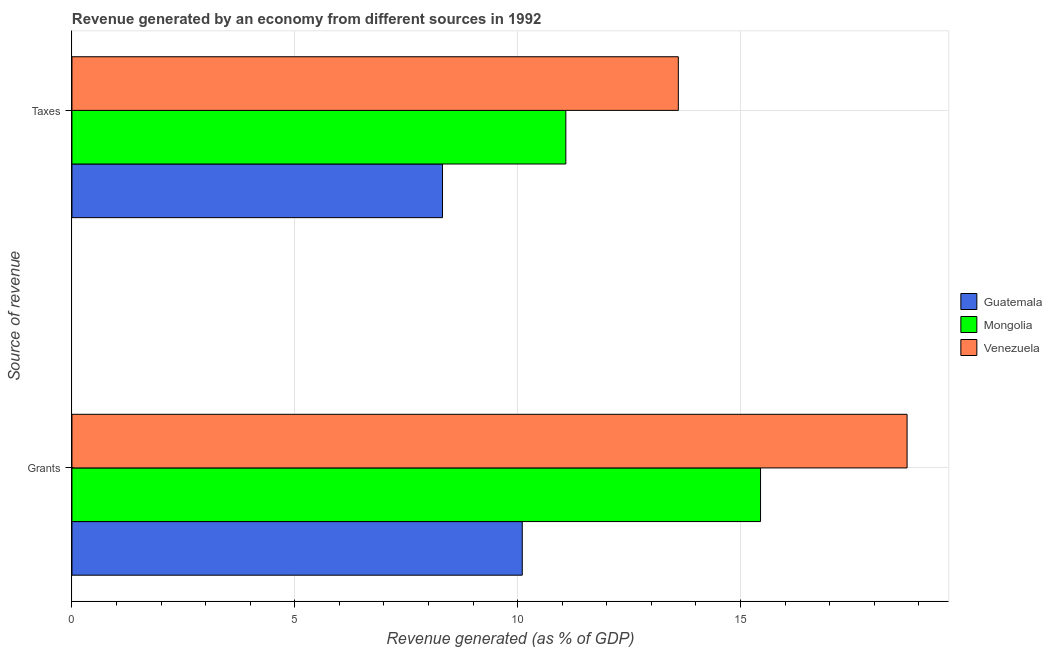How many groups of bars are there?
Your answer should be compact. 2. Are the number of bars per tick equal to the number of legend labels?
Ensure brevity in your answer.  Yes. Are the number of bars on each tick of the Y-axis equal?
Your response must be concise. Yes. What is the label of the 2nd group of bars from the top?
Ensure brevity in your answer.  Grants. What is the revenue generated by grants in Mongolia?
Your answer should be compact. 15.45. Across all countries, what is the maximum revenue generated by taxes?
Give a very brief answer. 13.6. Across all countries, what is the minimum revenue generated by taxes?
Give a very brief answer. 8.31. In which country was the revenue generated by taxes maximum?
Your response must be concise. Venezuela. In which country was the revenue generated by taxes minimum?
Offer a very short reply. Guatemala. What is the total revenue generated by grants in the graph?
Offer a terse response. 44.29. What is the difference between the revenue generated by taxes in Venezuela and that in Mongolia?
Provide a succinct answer. 2.52. What is the difference between the revenue generated by taxes in Guatemala and the revenue generated by grants in Mongolia?
Your answer should be compact. -7.14. What is the average revenue generated by grants per country?
Offer a terse response. 14.76. What is the difference between the revenue generated by grants and revenue generated by taxes in Venezuela?
Your response must be concise. 5.13. In how many countries, is the revenue generated by taxes greater than 13 %?
Provide a succinct answer. 1. What is the ratio of the revenue generated by taxes in Guatemala to that in Venezuela?
Provide a short and direct response. 0.61. Is the revenue generated by grants in Venezuela less than that in Mongolia?
Ensure brevity in your answer.  No. In how many countries, is the revenue generated by grants greater than the average revenue generated by grants taken over all countries?
Offer a terse response. 2. What does the 2nd bar from the top in Grants represents?
Ensure brevity in your answer.  Mongolia. What does the 2nd bar from the bottom in Grants represents?
Give a very brief answer. Mongolia. What is the difference between two consecutive major ticks on the X-axis?
Offer a terse response. 5. Does the graph contain any zero values?
Make the answer very short. No. Does the graph contain grids?
Your answer should be compact. Yes. How many legend labels are there?
Give a very brief answer. 3. How are the legend labels stacked?
Ensure brevity in your answer.  Vertical. What is the title of the graph?
Offer a terse response. Revenue generated by an economy from different sources in 1992. What is the label or title of the X-axis?
Give a very brief answer. Revenue generated (as % of GDP). What is the label or title of the Y-axis?
Your response must be concise. Source of revenue. What is the Revenue generated (as % of GDP) of Guatemala in Grants?
Provide a short and direct response. 10.1. What is the Revenue generated (as % of GDP) in Mongolia in Grants?
Ensure brevity in your answer.  15.45. What is the Revenue generated (as % of GDP) of Venezuela in Grants?
Offer a terse response. 18.74. What is the Revenue generated (as % of GDP) in Guatemala in Taxes?
Offer a very short reply. 8.31. What is the Revenue generated (as % of GDP) in Mongolia in Taxes?
Offer a very short reply. 11.08. What is the Revenue generated (as % of GDP) in Venezuela in Taxes?
Provide a short and direct response. 13.6. Across all Source of revenue, what is the maximum Revenue generated (as % of GDP) in Guatemala?
Your answer should be very brief. 10.1. Across all Source of revenue, what is the maximum Revenue generated (as % of GDP) of Mongolia?
Provide a short and direct response. 15.45. Across all Source of revenue, what is the maximum Revenue generated (as % of GDP) of Venezuela?
Make the answer very short. 18.74. Across all Source of revenue, what is the minimum Revenue generated (as % of GDP) in Guatemala?
Keep it short and to the point. 8.31. Across all Source of revenue, what is the minimum Revenue generated (as % of GDP) in Mongolia?
Keep it short and to the point. 11.08. Across all Source of revenue, what is the minimum Revenue generated (as % of GDP) of Venezuela?
Offer a very short reply. 13.6. What is the total Revenue generated (as % of GDP) of Guatemala in the graph?
Make the answer very short. 18.42. What is the total Revenue generated (as % of GDP) in Mongolia in the graph?
Keep it short and to the point. 26.53. What is the total Revenue generated (as % of GDP) of Venezuela in the graph?
Provide a short and direct response. 32.34. What is the difference between the Revenue generated (as % of GDP) in Guatemala in Grants and that in Taxes?
Ensure brevity in your answer.  1.79. What is the difference between the Revenue generated (as % of GDP) in Mongolia in Grants and that in Taxes?
Provide a succinct answer. 4.37. What is the difference between the Revenue generated (as % of GDP) of Venezuela in Grants and that in Taxes?
Keep it short and to the point. 5.13. What is the difference between the Revenue generated (as % of GDP) of Guatemala in Grants and the Revenue generated (as % of GDP) of Mongolia in Taxes?
Your answer should be very brief. -0.98. What is the difference between the Revenue generated (as % of GDP) of Guatemala in Grants and the Revenue generated (as % of GDP) of Venezuela in Taxes?
Provide a short and direct response. -3.5. What is the difference between the Revenue generated (as % of GDP) of Mongolia in Grants and the Revenue generated (as % of GDP) of Venezuela in Taxes?
Offer a very short reply. 1.84. What is the average Revenue generated (as % of GDP) in Guatemala per Source of revenue?
Provide a succinct answer. 9.21. What is the average Revenue generated (as % of GDP) of Mongolia per Source of revenue?
Offer a terse response. 13.27. What is the average Revenue generated (as % of GDP) of Venezuela per Source of revenue?
Give a very brief answer. 16.17. What is the difference between the Revenue generated (as % of GDP) in Guatemala and Revenue generated (as % of GDP) in Mongolia in Grants?
Your answer should be very brief. -5.35. What is the difference between the Revenue generated (as % of GDP) in Guatemala and Revenue generated (as % of GDP) in Venezuela in Grants?
Your answer should be very brief. -8.63. What is the difference between the Revenue generated (as % of GDP) of Mongolia and Revenue generated (as % of GDP) of Venezuela in Grants?
Provide a short and direct response. -3.29. What is the difference between the Revenue generated (as % of GDP) in Guatemala and Revenue generated (as % of GDP) in Mongolia in Taxes?
Offer a terse response. -2.77. What is the difference between the Revenue generated (as % of GDP) in Guatemala and Revenue generated (as % of GDP) in Venezuela in Taxes?
Your answer should be compact. -5.29. What is the difference between the Revenue generated (as % of GDP) of Mongolia and Revenue generated (as % of GDP) of Venezuela in Taxes?
Keep it short and to the point. -2.52. What is the ratio of the Revenue generated (as % of GDP) of Guatemala in Grants to that in Taxes?
Your response must be concise. 1.22. What is the ratio of the Revenue generated (as % of GDP) of Mongolia in Grants to that in Taxes?
Your answer should be very brief. 1.39. What is the ratio of the Revenue generated (as % of GDP) of Venezuela in Grants to that in Taxes?
Give a very brief answer. 1.38. What is the difference between the highest and the second highest Revenue generated (as % of GDP) of Guatemala?
Provide a succinct answer. 1.79. What is the difference between the highest and the second highest Revenue generated (as % of GDP) of Mongolia?
Keep it short and to the point. 4.37. What is the difference between the highest and the second highest Revenue generated (as % of GDP) of Venezuela?
Keep it short and to the point. 5.13. What is the difference between the highest and the lowest Revenue generated (as % of GDP) in Guatemala?
Provide a short and direct response. 1.79. What is the difference between the highest and the lowest Revenue generated (as % of GDP) of Mongolia?
Provide a short and direct response. 4.37. What is the difference between the highest and the lowest Revenue generated (as % of GDP) in Venezuela?
Your response must be concise. 5.13. 